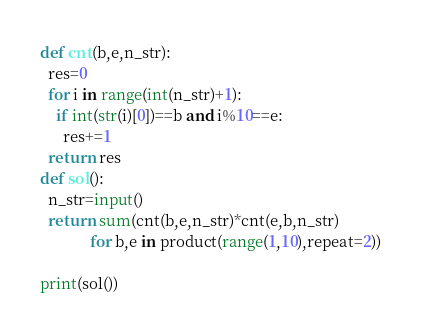<code> <loc_0><loc_0><loc_500><loc_500><_Python_>
def cnt(b,e,n_str):
  res=0
  for i in range(int(n_str)+1):
    if int(str(i)[0])==b and i%10==e:
      res+=1
  return res
def sol():
  n_str=input()
  return sum(cnt(b,e,n_str)*cnt(e,b,n_str) 
             for b,e in product(range(1,10),repeat=2))

print(sol())  
</code> 